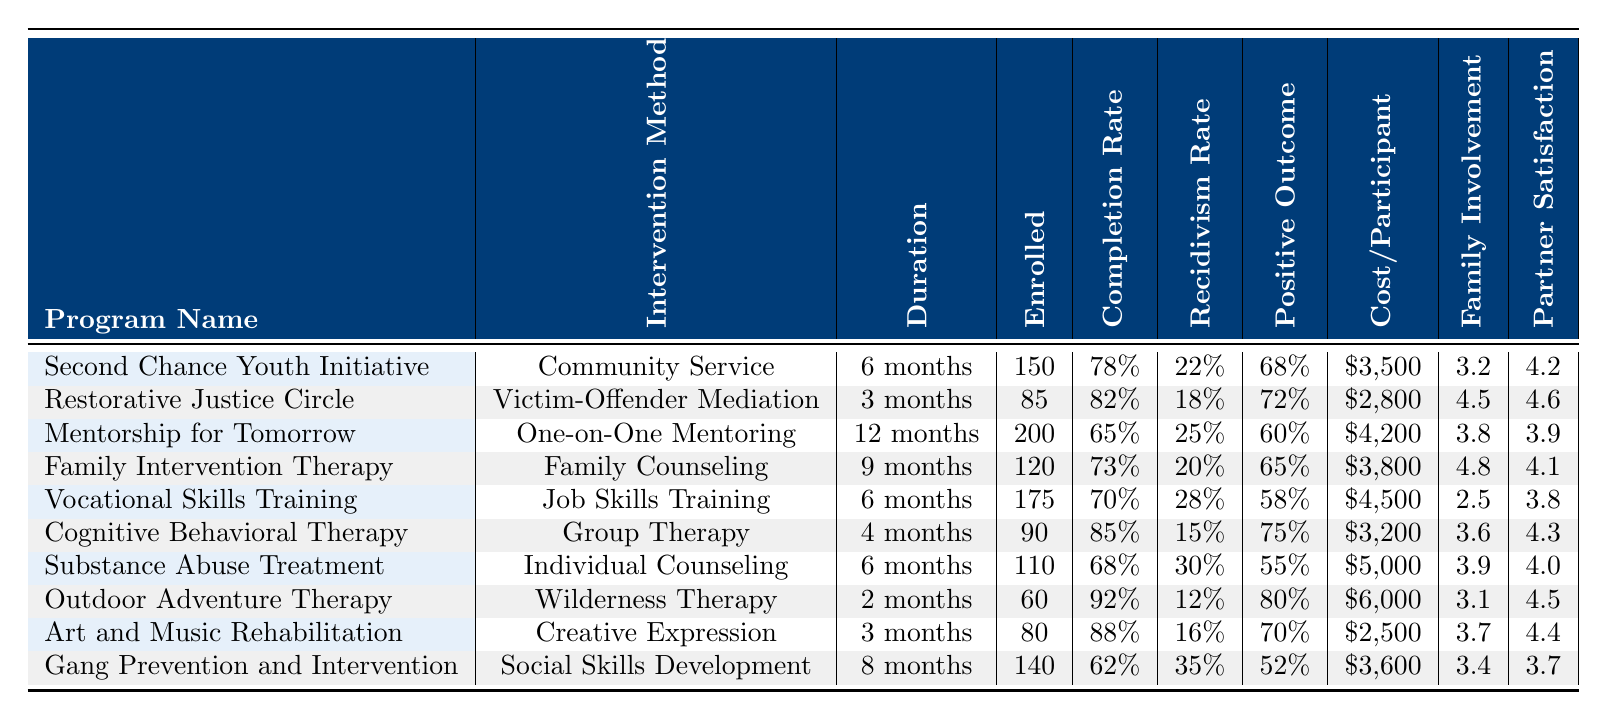What's the highest completion rate among the programs? The completion rates of the programs are listed in the table. The highest completion rate is 85%, which belongs to the Cognitive Behavioral Therapy Program.
Answer: 85% Which program has the lowest recidivism rate after one year? The recidivism rates are provided in the table, and the program with the lowest rate is Outdoor Adventure Therapy, with a rate of 12%.
Answer: 12% How many participants were enrolled in the Family Intervention Therapy program? The number of participants enrolled in the Family Intervention Therapy program is found in the table, which states that 120 participants were enrolled.
Answer: 120 What is the average cost per participant for all programs? The costs for each program are: $3,500, $2,800, $4,200, $3,800, $4,500, $3,200, $5,000, $6,000, $2,500, $3,600. Summing these gives $38,100. Dividing by the number of programs (10) gives an average cost of $3,810.
Answer: $3,810 Is there a program with a positive outcome rate higher than 75%? The positive outcome rates listed include values of 68%, 72%, 60%, 65%, 58%, 75%, 55%, 80%, 70%, and 52%. Yes, the Outdoor Adventure Therapy program has a positive outcome rate of 80%.
Answer: Yes What is the completion rate for the Vocational Skills Training program? The completion rate for Vocational Skills Training is available in the table and is stated as 70%.
Answer: 70% Which program had the highest number of participants enrolled, and what was that number? The table shows that the Mentorship for Tomorrow program had the highest enrollment, with 200 participants.
Answer: 200 If you combine the completion rates of the Cognitive Behavioral Therapy and Outdoor Adventure Therapy programs, what would that total be? The completion rates of these programs are 85% and 92%, respectively. Adding them gives 85% + 92% = 177%.
Answer: 177% What is the difference in family involvement scores between the highest and lowest rated programs? The family involvement scores are 4.8 for Family Intervention Therapy (highest) and 2.5 for Vocational Skills Training (lowest). The difference is 4.8 - 2.5 = 2.3.
Answer: 2.3 How many programs have a completion rate above 80%? The programs with completion rates above 80% are Restorative Justice Circle (82%) and Cognitive Behavioral Therapy (85%). Thus, there are 2 such programs.
Answer: 2 